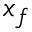Convert formula to latex. <formula><loc_0><loc_0><loc_500><loc_500>x _ { f }</formula> 